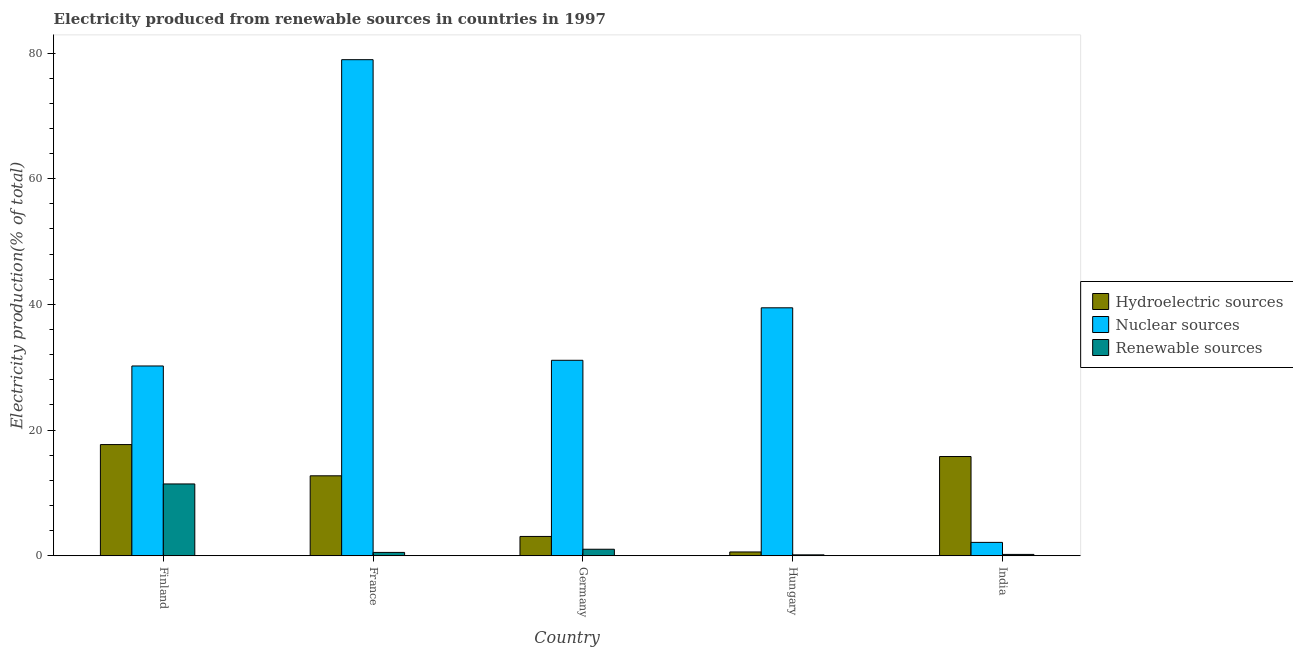Are the number of bars per tick equal to the number of legend labels?
Your answer should be very brief. Yes. In how many cases, is the number of bars for a given country not equal to the number of legend labels?
Keep it short and to the point. 0. What is the percentage of electricity produced by renewable sources in Finland?
Make the answer very short. 11.43. Across all countries, what is the maximum percentage of electricity produced by nuclear sources?
Your answer should be very brief. 78.94. Across all countries, what is the minimum percentage of electricity produced by renewable sources?
Provide a succinct answer. 0.15. In which country was the percentage of electricity produced by hydroelectric sources maximum?
Your answer should be very brief. Finland. In which country was the percentage of electricity produced by hydroelectric sources minimum?
Provide a short and direct response. Hungary. What is the total percentage of electricity produced by hydroelectric sources in the graph?
Your response must be concise. 49.91. What is the difference between the percentage of electricity produced by renewable sources in Finland and that in Hungary?
Give a very brief answer. 11.28. What is the difference between the percentage of electricity produced by renewable sources in India and the percentage of electricity produced by hydroelectric sources in France?
Provide a succinct answer. -12.51. What is the average percentage of electricity produced by nuclear sources per country?
Offer a very short reply. 36.37. What is the difference between the percentage of electricity produced by nuclear sources and percentage of electricity produced by renewable sources in Germany?
Ensure brevity in your answer.  30.07. What is the ratio of the percentage of electricity produced by renewable sources in France to that in India?
Make the answer very short. 2.44. Is the difference between the percentage of electricity produced by nuclear sources in Finland and India greater than the difference between the percentage of electricity produced by hydroelectric sources in Finland and India?
Offer a terse response. Yes. What is the difference between the highest and the second highest percentage of electricity produced by hydroelectric sources?
Keep it short and to the point. 1.9. What is the difference between the highest and the lowest percentage of electricity produced by renewable sources?
Provide a short and direct response. 11.28. Is the sum of the percentage of electricity produced by nuclear sources in Germany and India greater than the maximum percentage of electricity produced by hydroelectric sources across all countries?
Your answer should be compact. Yes. What does the 3rd bar from the left in Germany represents?
Your answer should be compact. Renewable sources. What does the 3rd bar from the right in Finland represents?
Provide a succinct answer. Hydroelectric sources. Is it the case that in every country, the sum of the percentage of electricity produced by hydroelectric sources and percentage of electricity produced by nuclear sources is greater than the percentage of electricity produced by renewable sources?
Offer a very short reply. Yes. How many bars are there?
Your answer should be very brief. 15. Are all the bars in the graph horizontal?
Keep it short and to the point. No. How many countries are there in the graph?
Your answer should be very brief. 5. Does the graph contain any zero values?
Your answer should be very brief. No. Where does the legend appear in the graph?
Provide a succinct answer. Center right. What is the title of the graph?
Give a very brief answer. Electricity produced from renewable sources in countries in 1997. Does "Ages 20-60" appear as one of the legend labels in the graph?
Your answer should be very brief. No. What is the Electricity production(% of total) of Hydroelectric sources in Finland?
Your answer should be compact. 17.7. What is the Electricity production(% of total) of Nuclear sources in Finland?
Offer a terse response. 30.2. What is the Electricity production(% of total) in Renewable sources in Finland?
Offer a terse response. 11.43. What is the Electricity production(% of total) of Hydroelectric sources in France?
Give a very brief answer. 12.73. What is the Electricity production(% of total) of Nuclear sources in France?
Offer a very short reply. 78.94. What is the Electricity production(% of total) in Renewable sources in France?
Offer a very short reply. 0.54. What is the Electricity production(% of total) in Hydroelectric sources in Germany?
Keep it short and to the point. 3.08. What is the Electricity production(% of total) in Nuclear sources in Germany?
Your response must be concise. 31.11. What is the Electricity production(% of total) in Renewable sources in Germany?
Offer a very short reply. 1.04. What is the Electricity production(% of total) in Hydroelectric sources in Hungary?
Ensure brevity in your answer.  0.61. What is the Electricity production(% of total) in Nuclear sources in Hungary?
Provide a short and direct response. 39.46. What is the Electricity production(% of total) in Renewable sources in Hungary?
Your response must be concise. 0.15. What is the Electricity production(% of total) of Hydroelectric sources in India?
Ensure brevity in your answer.  15.8. What is the Electricity production(% of total) of Nuclear sources in India?
Offer a terse response. 2.13. What is the Electricity production(% of total) of Renewable sources in India?
Ensure brevity in your answer.  0.22. Across all countries, what is the maximum Electricity production(% of total) in Hydroelectric sources?
Provide a succinct answer. 17.7. Across all countries, what is the maximum Electricity production(% of total) in Nuclear sources?
Provide a short and direct response. 78.94. Across all countries, what is the maximum Electricity production(% of total) of Renewable sources?
Your response must be concise. 11.43. Across all countries, what is the minimum Electricity production(% of total) of Hydroelectric sources?
Keep it short and to the point. 0.61. Across all countries, what is the minimum Electricity production(% of total) in Nuclear sources?
Provide a short and direct response. 2.13. Across all countries, what is the minimum Electricity production(% of total) in Renewable sources?
Your answer should be compact. 0.15. What is the total Electricity production(% of total) of Hydroelectric sources in the graph?
Provide a succinct answer. 49.91. What is the total Electricity production(% of total) in Nuclear sources in the graph?
Your answer should be very brief. 181.85. What is the total Electricity production(% of total) in Renewable sources in the graph?
Your answer should be compact. 13.38. What is the difference between the Electricity production(% of total) of Hydroelectric sources in Finland and that in France?
Provide a short and direct response. 4.97. What is the difference between the Electricity production(% of total) of Nuclear sources in Finland and that in France?
Make the answer very short. -48.74. What is the difference between the Electricity production(% of total) of Renewable sources in Finland and that in France?
Provide a short and direct response. 10.9. What is the difference between the Electricity production(% of total) in Hydroelectric sources in Finland and that in Germany?
Give a very brief answer. 14.62. What is the difference between the Electricity production(% of total) in Nuclear sources in Finland and that in Germany?
Your answer should be compact. -0.91. What is the difference between the Electricity production(% of total) of Renewable sources in Finland and that in Germany?
Offer a terse response. 10.39. What is the difference between the Electricity production(% of total) in Hydroelectric sources in Finland and that in Hungary?
Offer a terse response. 17.09. What is the difference between the Electricity production(% of total) in Nuclear sources in Finland and that in Hungary?
Offer a terse response. -9.26. What is the difference between the Electricity production(% of total) in Renewable sources in Finland and that in Hungary?
Provide a short and direct response. 11.28. What is the difference between the Electricity production(% of total) in Hydroelectric sources in Finland and that in India?
Provide a short and direct response. 1.9. What is the difference between the Electricity production(% of total) in Nuclear sources in Finland and that in India?
Make the answer very short. 28.07. What is the difference between the Electricity production(% of total) in Renewable sources in Finland and that in India?
Offer a very short reply. 11.21. What is the difference between the Electricity production(% of total) in Hydroelectric sources in France and that in Germany?
Offer a very short reply. 9.65. What is the difference between the Electricity production(% of total) in Nuclear sources in France and that in Germany?
Offer a terse response. 47.83. What is the difference between the Electricity production(% of total) in Renewable sources in France and that in Germany?
Give a very brief answer. -0.51. What is the difference between the Electricity production(% of total) in Hydroelectric sources in France and that in Hungary?
Offer a very short reply. 12.12. What is the difference between the Electricity production(% of total) in Nuclear sources in France and that in Hungary?
Provide a succinct answer. 39.48. What is the difference between the Electricity production(% of total) of Renewable sources in France and that in Hungary?
Your answer should be compact. 0.39. What is the difference between the Electricity production(% of total) of Hydroelectric sources in France and that in India?
Ensure brevity in your answer.  -3.07. What is the difference between the Electricity production(% of total) in Nuclear sources in France and that in India?
Make the answer very short. 76.81. What is the difference between the Electricity production(% of total) in Renewable sources in France and that in India?
Offer a terse response. 0.32. What is the difference between the Electricity production(% of total) of Hydroelectric sources in Germany and that in Hungary?
Offer a very short reply. 2.47. What is the difference between the Electricity production(% of total) of Nuclear sources in Germany and that in Hungary?
Make the answer very short. -8.35. What is the difference between the Electricity production(% of total) in Renewable sources in Germany and that in Hungary?
Ensure brevity in your answer.  0.89. What is the difference between the Electricity production(% of total) in Hydroelectric sources in Germany and that in India?
Provide a short and direct response. -12.72. What is the difference between the Electricity production(% of total) in Nuclear sources in Germany and that in India?
Provide a short and direct response. 28.98. What is the difference between the Electricity production(% of total) of Renewable sources in Germany and that in India?
Your answer should be compact. 0.82. What is the difference between the Electricity production(% of total) of Hydroelectric sources in Hungary and that in India?
Offer a terse response. -15.19. What is the difference between the Electricity production(% of total) of Nuclear sources in Hungary and that in India?
Offer a terse response. 37.33. What is the difference between the Electricity production(% of total) in Renewable sources in Hungary and that in India?
Provide a succinct answer. -0.07. What is the difference between the Electricity production(% of total) in Hydroelectric sources in Finland and the Electricity production(% of total) in Nuclear sources in France?
Ensure brevity in your answer.  -61.25. What is the difference between the Electricity production(% of total) in Hydroelectric sources in Finland and the Electricity production(% of total) in Renewable sources in France?
Offer a terse response. 17.16. What is the difference between the Electricity production(% of total) in Nuclear sources in Finland and the Electricity production(% of total) in Renewable sources in France?
Provide a short and direct response. 29.67. What is the difference between the Electricity production(% of total) of Hydroelectric sources in Finland and the Electricity production(% of total) of Nuclear sources in Germany?
Make the answer very short. -13.41. What is the difference between the Electricity production(% of total) in Hydroelectric sources in Finland and the Electricity production(% of total) in Renewable sources in Germany?
Ensure brevity in your answer.  16.65. What is the difference between the Electricity production(% of total) in Nuclear sources in Finland and the Electricity production(% of total) in Renewable sources in Germany?
Your response must be concise. 29.16. What is the difference between the Electricity production(% of total) in Hydroelectric sources in Finland and the Electricity production(% of total) in Nuclear sources in Hungary?
Your answer should be very brief. -21.76. What is the difference between the Electricity production(% of total) of Hydroelectric sources in Finland and the Electricity production(% of total) of Renewable sources in Hungary?
Ensure brevity in your answer.  17.55. What is the difference between the Electricity production(% of total) of Nuclear sources in Finland and the Electricity production(% of total) of Renewable sources in Hungary?
Provide a short and direct response. 30.05. What is the difference between the Electricity production(% of total) in Hydroelectric sources in Finland and the Electricity production(% of total) in Nuclear sources in India?
Your answer should be very brief. 15.56. What is the difference between the Electricity production(% of total) of Hydroelectric sources in Finland and the Electricity production(% of total) of Renewable sources in India?
Your answer should be compact. 17.48. What is the difference between the Electricity production(% of total) of Nuclear sources in Finland and the Electricity production(% of total) of Renewable sources in India?
Give a very brief answer. 29.98. What is the difference between the Electricity production(% of total) of Hydroelectric sources in France and the Electricity production(% of total) of Nuclear sources in Germany?
Ensure brevity in your answer.  -18.38. What is the difference between the Electricity production(% of total) in Hydroelectric sources in France and the Electricity production(% of total) in Renewable sources in Germany?
Keep it short and to the point. 11.69. What is the difference between the Electricity production(% of total) of Nuclear sources in France and the Electricity production(% of total) of Renewable sources in Germany?
Your answer should be compact. 77.9. What is the difference between the Electricity production(% of total) of Hydroelectric sources in France and the Electricity production(% of total) of Nuclear sources in Hungary?
Keep it short and to the point. -26.73. What is the difference between the Electricity production(% of total) of Hydroelectric sources in France and the Electricity production(% of total) of Renewable sources in Hungary?
Your answer should be compact. 12.58. What is the difference between the Electricity production(% of total) in Nuclear sources in France and the Electricity production(% of total) in Renewable sources in Hungary?
Ensure brevity in your answer.  78.79. What is the difference between the Electricity production(% of total) in Hydroelectric sources in France and the Electricity production(% of total) in Nuclear sources in India?
Ensure brevity in your answer.  10.59. What is the difference between the Electricity production(% of total) in Hydroelectric sources in France and the Electricity production(% of total) in Renewable sources in India?
Provide a short and direct response. 12.51. What is the difference between the Electricity production(% of total) of Nuclear sources in France and the Electricity production(% of total) of Renewable sources in India?
Ensure brevity in your answer.  78.72. What is the difference between the Electricity production(% of total) of Hydroelectric sources in Germany and the Electricity production(% of total) of Nuclear sources in Hungary?
Your response must be concise. -36.38. What is the difference between the Electricity production(% of total) of Hydroelectric sources in Germany and the Electricity production(% of total) of Renewable sources in Hungary?
Your answer should be very brief. 2.93. What is the difference between the Electricity production(% of total) of Nuclear sources in Germany and the Electricity production(% of total) of Renewable sources in Hungary?
Your response must be concise. 30.96. What is the difference between the Electricity production(% of total) in Hydroelectric sources in Germany and the Electricity production(% of total) in Nuclear sources in India?
Keep it short and to the point. 0.95. What is the difference between the Electricity production(% of total) in Hydroelectric sources in Germany and the Electricity production(% of total) in Renewable sources in India?
Make the answer very short. 2.86. What is the difference between the Electricity production(% of total) of Nuclear sources in Germany and the Electricity production(% of total) of Renewable sources in India?
Keep it short and to the point. 30.89. What is the difference between the Electricity production(% of total) of Hydroelectric sources in Hungary and the Electricity production(% of total) of Nuclear sources in India?
Offer a very short reply. -1.52. What is the difference between the Electricity production(% of total) in Hydroelectric sources in Hungary and the Electricity production(% of total) in Renewable sources in India?
Ensure brevity in your answer.  0.39. What is the difference between the Electricity production(% of total) in Nuclear sources in Hungary and the Electricity production(% of total) in Renewable sources in India?
Give a very brief answer. 39.24. What is the average Electricity production(% of total) of Hydroelectric sources per country?
Your response must be concise. 9.98. What is the average Electricity production(% of total) of Nuclear sources per country?
Provide a succinct answer. 36.37. What is the average Electricity production(% of total) in Renewable sources per country?
Your response must be concise. 2.68. What is the difference between the Electricity production(% of total) of Hydroelectric sources and Electricity production(% of total) of Nuclear sources in Finland?
Provide a succinct answer. -12.51. What is the difference between the Electricity production(% of total) of Hydroelectric sources and Electricity production(% of total) of Renewable sources in Finland?
Provide a succinct answer. 6.26. What is the difference between the Electricity production(% of total) in Nuclear sources and Electricity production(% of total) in Renewable sources in Finland?
Keep it short and to the point. 18.77. What is the difference between the Electricity production(% of total) in Hydroelectric sources and Electricity production(% of total) in Nuclear sources in France?
Ensure brevity in your answer.  -66.21. What is the difference between the Electricity production(% of total) of Hydroelectric sources and Electricity production(% of total) of Renewable sources in France?
Make the answer very short. 12.19. What is the difference between the Electricity production(% of total) in Nuclear sources and Electricity production(% of total) in Renewable sources in France?
Provide a succinct answer. 78.41. What is the difference between the Electricity production(% of total) in Hydroelectric sources and Electricity production(% of total) in Nuclear sources in Germany?
Keep it short and to the point. -28.03. What is the difference between the Electricity production(% of total) of Hydroelectric sources and Electricity production(% of total) of Renewable sources in Germany?
Provide a short and direct response. 2.04. What is the difference between the Electricity production(% of total) of Nuclear sources and Electricity production(% of total) of Renewable sources in Germany?
Provide a short and direct response. 30.07. What is the difference between the Electricity production(% of total) in Hydroelectric sources and Electricity production(% of total) in Nuclear sources in Hungary?
Give a very brief answer. -38.85. What is the difference between the Electricity production(% of total) in Hydroelectric sources and Electricity production(% of total) in Renewable sources in Hungary?
Give a very brief answer. 0.46. What is the difference between the Electricity production(% of total) of Nuclear sources and Electricity production(% of total) of Renewable sources in Hungary?
Make the answer very short. 39.31. What is the difference between the Electricity production(% of total) in Hydroelectric sources and Electricity production(% of total) in Nuclear sources in India?
Make the answer very short. 13.66. What is the difference between the Electricity production(% of total) in Hydroelectric sources and Electricity production(% of total) in Renewable sources in India?
Your answer should be compact. 15.58. What is the difference between the Electricity production(% of total) in Nuclear sources and Electricity production(% of total) in Renewable sources in India?
Offer a terse response. 1.91. What is the ratio of the Electricity production(% of total) in Hydroelectric sources in Finland to that in France?
Keep it short and to the point. 1.39. What is the ratio of the Electricity production(% of total) in Nuclear sources in Finland to that in France?
Offer a very short reply. 0.38. What is the ratio of the Electricity production(% of total) in Renewable sources in Finland to that in France?
Give a very brief answer. 21.29. What is the ratio of the Electricity production(% of total) of Hydroelectric sources in Finland to that in Germany?
Make the answer very short. 5.75. What is the ratio of the Electricity production(% of total) of Nuclear sources in Finland to that in Germany?
Make the answer very short. 0.97. What is the ratio of the Electricity production(% of total) in Renewable sources in Finland to that in Germany?
Your answer should be very brief. 10.97. What is the ratio of the Electricity production(% of total) of Hydroelectric sources in Finland to that in Hungary?
Keep it short and to the point. 29. What is the ratio of the Electricity production(% of total) of Nuclear sources in Finland to that in Hungary?
Ensure brevity in your answer.  0.77. What is the ratio of the Electricity production(% of total) of Renewable sources in Finland to that in Hungary?
Offer a very short reply. 76.36. What is the ratio of the Electricity production(% of total) in Hydroelectric sources in Finland to that in India?
Provide a short and direct response. 1.12. What is the ratio of the Electricity production(% of total) of Nuclear sources in Finland to that in India?
Offer a terse response. 14.16. What is the ratio of the Electricity production(% of total) of Renewable sources in Finland to that in India?
Make the answer very short. 52.01. What is the ratio of the Electricity production(% of total) in Hydroelectric sources in France to that in Germany?
Offer a very short reply. 4.13. What is the ratio of the Electricity production(% of total) in Nuclear sources in France to that in Germany?
Provide a succinct answer. 2.54. What is the ratio of the Electricity production(% of total) in Renewable sources in France to that in Germany?
Give a very brief answer. 0.52. What is the ratio of the Electricity production(% of total) of Hydroelectric sources in France to that in Hungary?
Your response must be concise. 20.86. What is the ratio of the Electricity production(% of total) of Nuclear sources in France to that in Hungary?
Your answer should be compact. 2. What is the ratio of the Electricity production(% of total) in Renewable sources in France to that in Hungary?
Offer a very short reply. 3.59. What is the ratio of the Electricity production(% of total) of Hydroelectric sources in France to that in India?
Provide a succinct answer. 0.81. What is the ratio of the Electricity production(% of total) of Nuclear sources in France to that in India?
Your answer should be compact. 37.01. What is the ratio of the Electricity production(% of total) of Renewable sources in France to that in India?
Offer a terse response. 2.44. What is the ratio of the Electricity production(% of total) in Hydroelectric sources in Germany to that in Hungary?
Offer a terse response. 5.05. What is the ratio of the Electricity production(% of total) of Nuclear sources in Germany to that in Hungary?
Provide a short and direct response. 0.79. What is the ratio of the Electricity production(% of total) of Renewable sources in Germany to that in Hungary?
Your answer should be very brief. 6.96. What is the ratio of the Electricity production(% of total) in Hydroelectric sources in Germany to that in India?
Offer a terse response. 0.19. What is the ratio of the Electricity production(% of total) in Nuclear sources in Germany to that in India?
Your answer should be compact. 14.58. What is the ratio of the Electricity production(% of total) in Renewable sources in Germany to that in India?
Your answer should be very brief. 4.74. What is the ratio of the Electricity production(% of total) in Hydroelectric sources in Hungary to that in India?
Offer a terse response. 0.04. What is the ratio of the Electricity production(% of total) of Nuclear sources in Hungary to that in India?
Ensure brevity in your answer.  18.5. What is the ratio of the Electricity production(% of total) in Renewable sources in Hungary to that in India?
Offer a very short reply. 0.68. What is the difference between the highest and the second highest Electricity production(% of total) of Hydroelectric sources?
Make the answer very short. 1.9. What is the difference between the highest and the second highest Electricity production(% of total) in Nuclear sources?
Your response must be concise. 39.48. What is the difference between the highest and the second highest Electricity production(% of total) of Renewable sources?
Provide a short and direct response. 10.39. What is the difference between the highest and the lowest Electricity production(% of total) in Hydroelectric sources?
Offer a very short reply. 17.09. What is the difference between the highest and the lowest Electricity production(% of total) of Nuclear sources?
Offer a terse response. 76.81. What is the difference between the highest and the lowest Electricity production(% of total) of Renewable sources?
Provide a short and direct response. 11.28. 